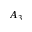<formula> <loc_0><loc_0><loc_500><loc_500>A _ { 3 }</formula> 